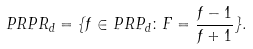<formula> <loc_0><loc_0><loc_500><loc_500>P R P R _ { d } = \{ f \in P R P _ { d } \colon F = \frac { f - 1 } { f + 1 } \} .</formula> 